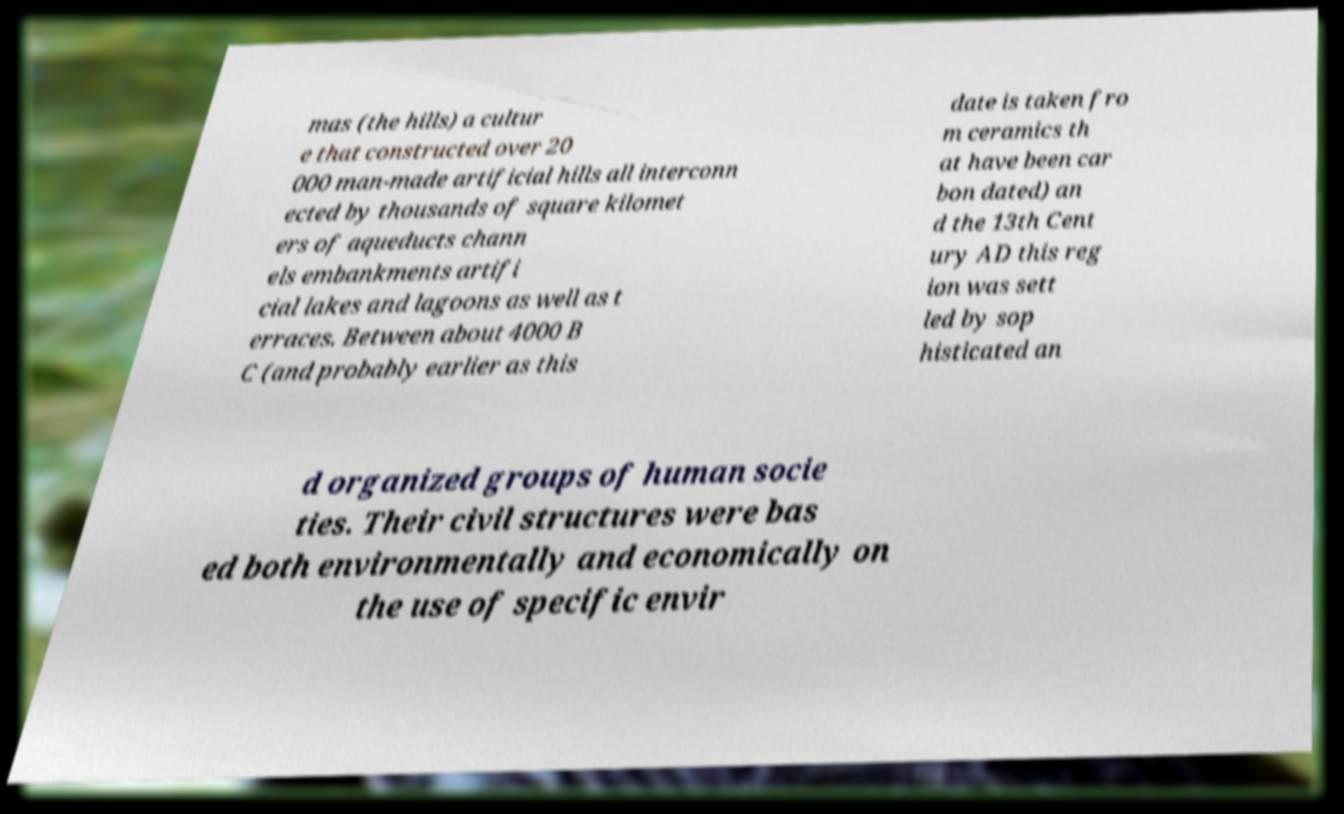Could you assist in decoding the text presented in this image and type it out clearly? mas (the hills) a cultur e that constructed over 20 000 man-made artificial hills all interconn ected by thousands of square kilomet ers of aqueducts chann els embankments artifi cial lakes and lagoons as well as t erraces. Between about 4000 B C (and probably earlier as this date is taken fro m ceramics th at have been car bon dated) an d the 13th Cent ury AD this reg ion was sett led by sop histicated an d organized groups of human socie ties. Their civil structures were bas ed both environmentally and economically on the use of specific envir 